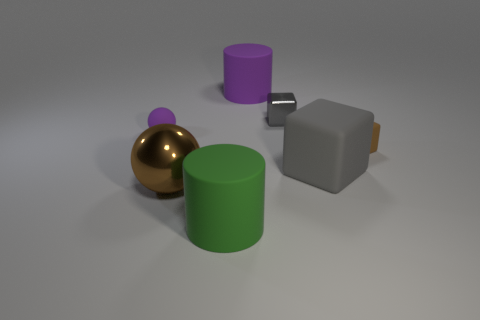What number of objects are big rubber cylinders that are in front of the big metallic object or tiny blocks?
Ensure brevity in your answer.  3. There is another cube that is the same color as the shiny cube; what is its material?
Your response must be concise. Rubber. There is a brown thing that is left of the large cylinder that is in front of the brown matte thing; are there any purple cylinders that are in front of it?
Give a very brief answer. No. Is the number of big rubber objects that are left of the brown metal sphere less than the number of objects to the left of the gray matte block?
Provide a succinct answer. Yes. What color is the small block that is made of the same material as the green cylinder?
Your answer should be compact. Brown. The cylinder that is behind the small matte thing right of the green rubber thing is what color?
Provide a short and direct response. Purple. Are there any small objects that have the same color as the metallic sphere?
Your answer should be very brief. Yes. The purple rubber thing that is the same size as the brown rubber thing is what shape?
Ensure brevity in your answer.  Sphere. There is a large matte cylinder that is behind the big gray object; how many brown metallic balls are right of it?
Ensure brevity in your answer.  0. Is the metal ball the same color as the tiny matte block?
Your answer should be very brief. Yes. 